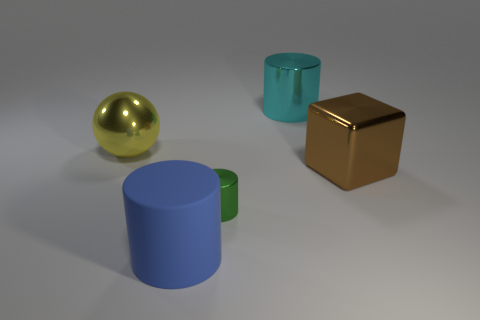What is the shape of the thing that is both right of the large rubber thing and in front of the big metal cube?
Offer a very short reply. Cylinder. Is there anything else that has the same size as the matte cylinder?
Your answer should be compact. Yes. There is a green thing that is made of the same material as the yellow sphere; what is its size?
Provide a short and direct response. Small. How many objects are either cylinders behind the brown metal cube or large shiny objects in front of the cyan cylinder?
Offer a very short reply. 3. There is a brown metallic block on the right side of the blue thing; is its size the same as the blue matte object?
Your answer should be very brief. Yes. There is a shiny cylinder that is in front of the brown object; what is its color?
Provide a succinct answer. Green. What is the color of the other small metallic thing that is the same shape as the cyan thing?
Make the answer very short. Green. There is a metal cylinder behind the shiny cylinder in front of the block; what number of large yellow metallic balls are behind it?
Offer a terse response. 0. Are there any other things that are made of the same material as the blue cylinder?
Provide a short and direct response. No. Is the number of large brown shiny cubes behind the big brown metal cube less than the number of red metallic cubes?
Provide a succinct answer. No. 